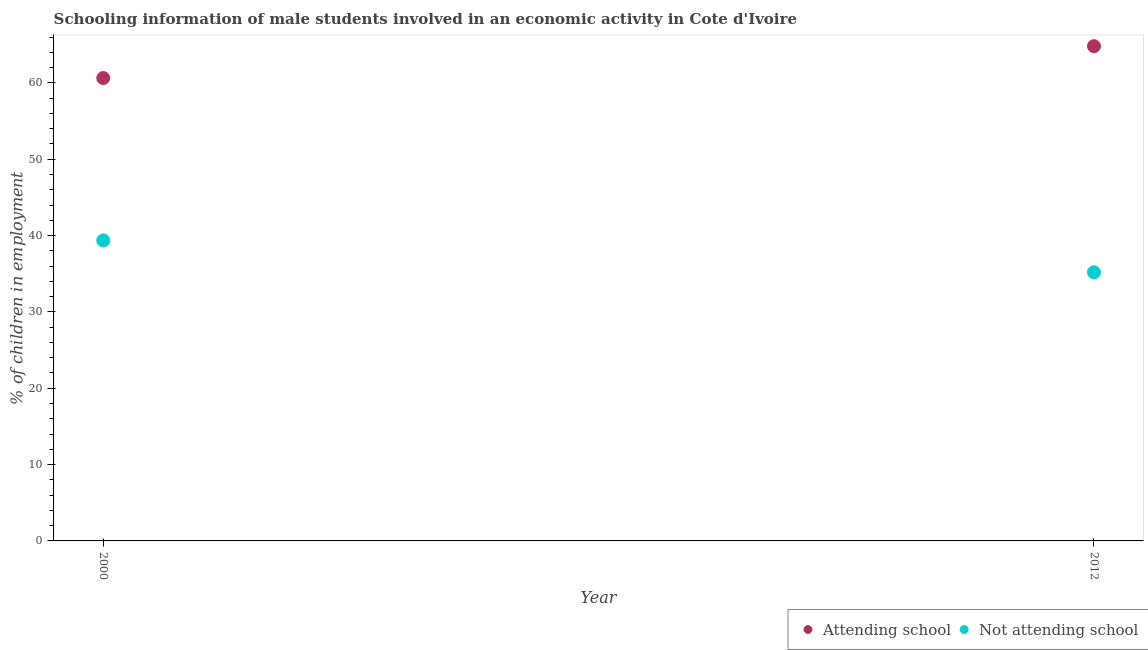How many different coloured dotlines are there?
Offer a very short reply. 2. Is the number of dotlines equal to the number of legend labels?
Offer a very short reply. Yes. What is the percentage of employed males who are not attending school in 2012?
Your answer should be compact. 35.19. Across all years, what is the maximum percentage of employed males who are not attending school?
Your answer should be compact. 39.36. Across all years, what is the minimum percentage of employed males who are not attending school?
Your answer should be compact. 35.19. What is the total percentage of employed males who are not attending school in the graph?
Make the answer very short. 74.56. What is the difference between the percentage of employed males who are attending school in 2000 and that in 2012?
Ensure brevity in your answer.  -4.17. What is the difference between the percentage of employed males who are attending school in 2012 and the percentage of employed males who are not attending school in 2000?
Keep it short and to the point. 25.44. What is the average percentage of employed males who are not attending school per year?
Offer a terse response. 37.28. In the year 2012, what is the difference between the percentage of employed males who are attending school and percentage of employed males who are not attending school?
Your response must be concise. 29.62. In how many years, is the percentage of employed males who are not attending school greater than 48 %?
Offer a terse response. 0. What is the ratio of the percentage of employed males who are attending school in 2000 to that in 2012?
Provide a short and direct response. 0.94. Is the percentage of employed males who are not attending school in 2000 less than that in 2012?
Offer a very short reply. No. Does the percentage of employed males who are attending school monotonically increase over the years?
Provide a succinct answer. Yes. What is the difference between two consecutive major ticks on the Y-axis?
Your response must be concise. 10. Does the graph contain any zero values?
Make the answer very short. No. How many legend labels are there?
Provide a succinct answer. 2. How are the legend labels stacked?
Give a very brief answer. Horizontal. What is the title of the graph?
Make the answer very short. Schooling information of male students involved in an economic activity in Cote d'Ivoire. What is the label or title of the X-axis?
Your answer should be very brief. Year. What is the label or title of the Y-axis?
Give a very brief answer. % of children in employment. What is the % of children in employment in Attending school in 2000?
Offer a terse response. 60.64. What is the % of children in employment in Not attending school in 2000?
Offer a terse response. 39.36. What is the % of children in employment of Attending school in 2012?
Offer a terse response. 64.81. What is the % of children in employment of Not attending school in 2012?
Make the answer very short. 35.19. Across all years, what is the maximum % of children in employment in Attending school?
Provide a short and direct response. 64.81. Across all years, what is the maximum % of children in employment in Not attending school?
Offer a terse response. 39.36. Across all years, what is the minimum % of children in employment of Attending school?
Make the answer very short. 60.64. Across all years, what is the minimum % of children in employment of Not attending school?
Give a very brief answer. 35.19. What is the total % of children in employment of Attending school in the graph?
Make the answer very short. 125.44. What is the total % of children in employment of Not attending school in the graph?
Offer a very short reply. 74.56. What is the difference between the % of children in employment in Attending school in 2000 and that in 2012?
Provide a succinct answer. -4.17. What is the difference between the % of children in employment of Not attending school in 2000 and that in 2012?
Your answer should be very brief. 4.17. What is the difference between the % of children in employment in Attending school in 2000 and the % of children in employment in Not attending school in 2012?
Your answer should be compact. 25.44. What is the average % of children in employment in Attending school per year?
Offer a terse response. 62.72. What is the average % of children in employment of Not attending school per year?
Your answer should be compact. 37.28. In the year 2000, what is the difference between the % of children in employment of Attending school and % of children in employment of Not attending school?
Provide a short and direct response. 21.27. In the year 2012, what is the difference between the % of children in employment in Attending school and % of children in employment in Not attending school?
Keep it short and to the point. 29.62. What is the ratio of the % of children in employment in Attending school in 2000 to that in 2012?
Offer a very short reply. 0.94. What is the ratio of the % of children in employment in Not attending school in 2000 to that in 2012?
Your answer should be very brief. 1.12. What is the difference between the highest and the second highest % of children in employment of Attending school?
Provide a short and direct response. 4.17. What is the difference between the highest and the second highest % of children in employment in Not attending school?
Keep it short and to the point. 4.17. What is the difference between the highest and the lowest % of children in employment of Attending school?
Your response must be concise. 4.17. What is the difference between the highest and the lowest % of children in employment in Not attending school?
Your answer should be compact. 4.17. 